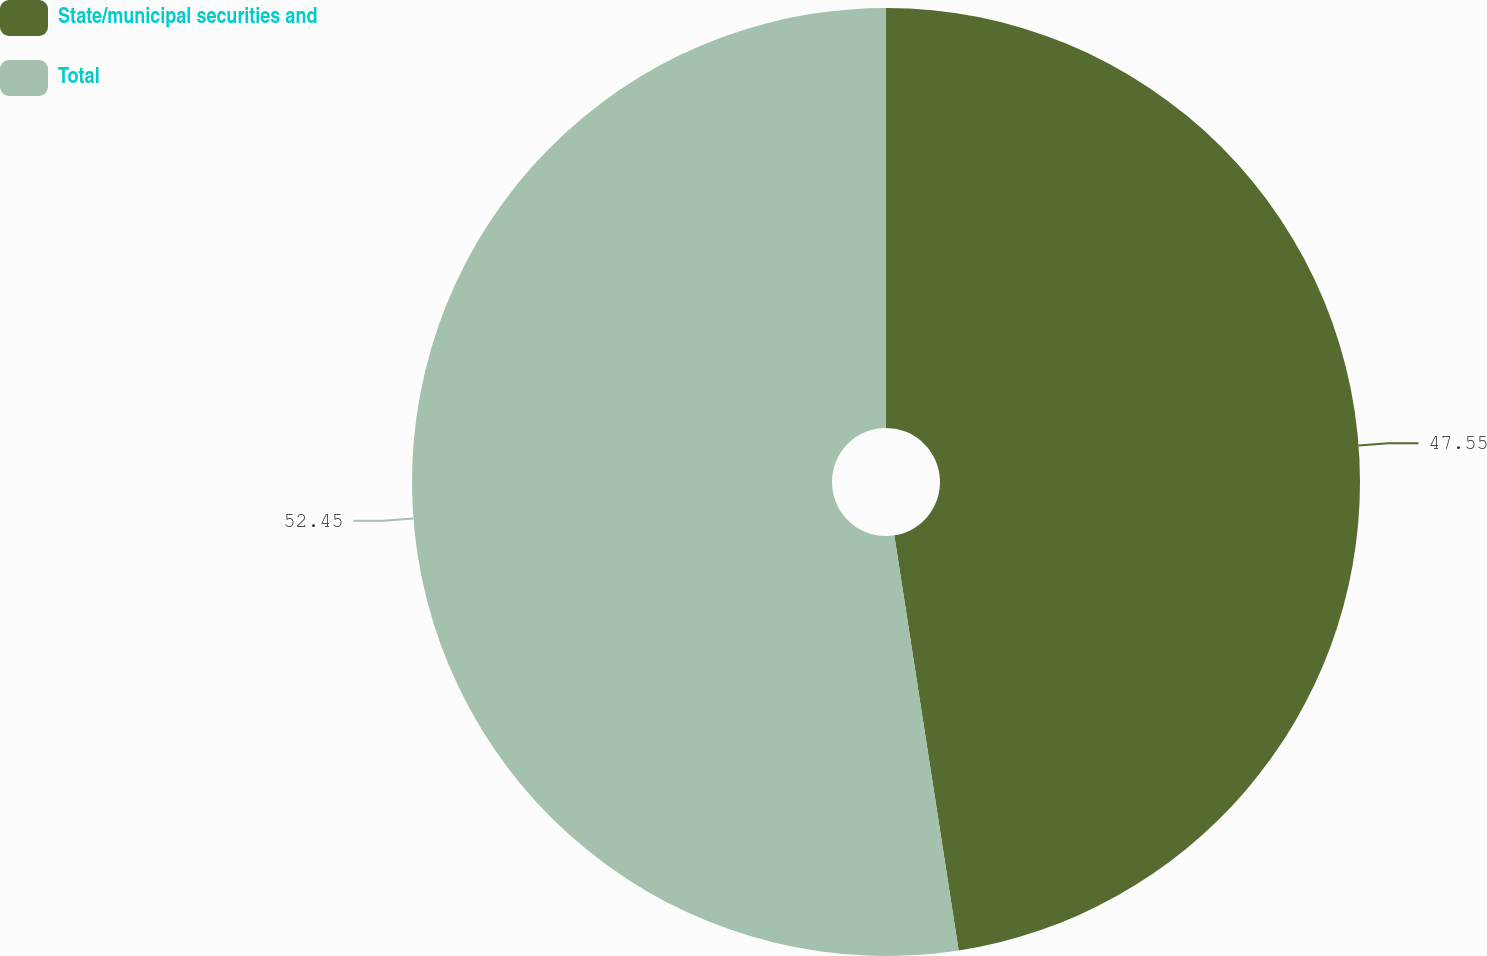<chart> <loc_0><loc_0><loc_500><loc_500><pie_chart><fcel>State/municipal securities and<fcel>Total<nl><fcel>47.55%<fcel>52.45%<nl></chart> 